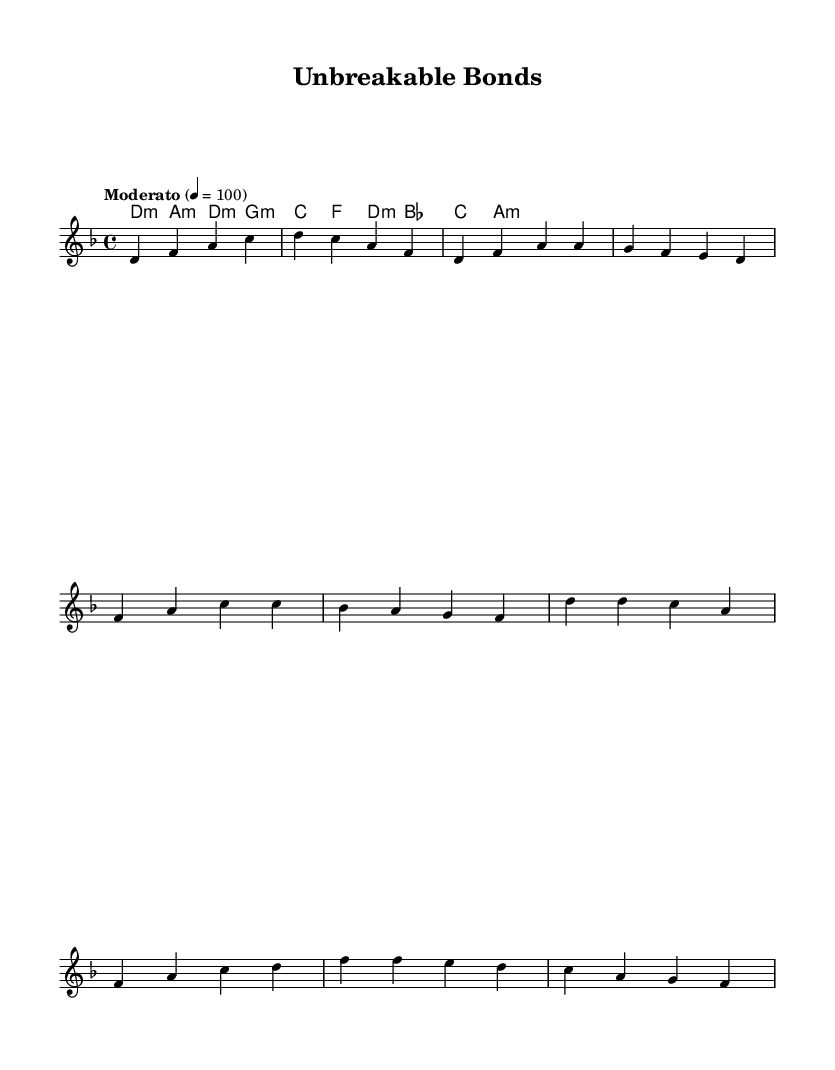What is the key signature of this music? The key signature is D minor, which is indicated by one flat (B♭) in the key signature.
Answer: D minor What is the time signature of this piece? The time signature is 4/4, which means there are four beats in each measure. This is indicated at the beginning of the music.
Answer: 4/4 What is the tempo marking for this piece? The tempo marking is "Moderato," indicating a moderate speed of 100 beats per minute, which can be inferred from the tempo instruction in the score.
Answer: Moderato How many measures are in the verse? The verse consists of four measures, which can be counted from the notation provided in the melody section.
Answer: 4 Which chord is played in the first measure of the intro? The chord in the first measure is D minor, as indicated by the chord symbols listed above the staff in the harmonies section.
Answer: D minor What is the final chord played in the chorus? The final chord in the chorus is A minor, which can be identified as the last chord corresponding to the notes in the melody and harmony sections.
Answer: A minor What is the note that starts the melody of the piece? The melody starts with the note D, which is the first note in the melody line provided.
Answer: D 